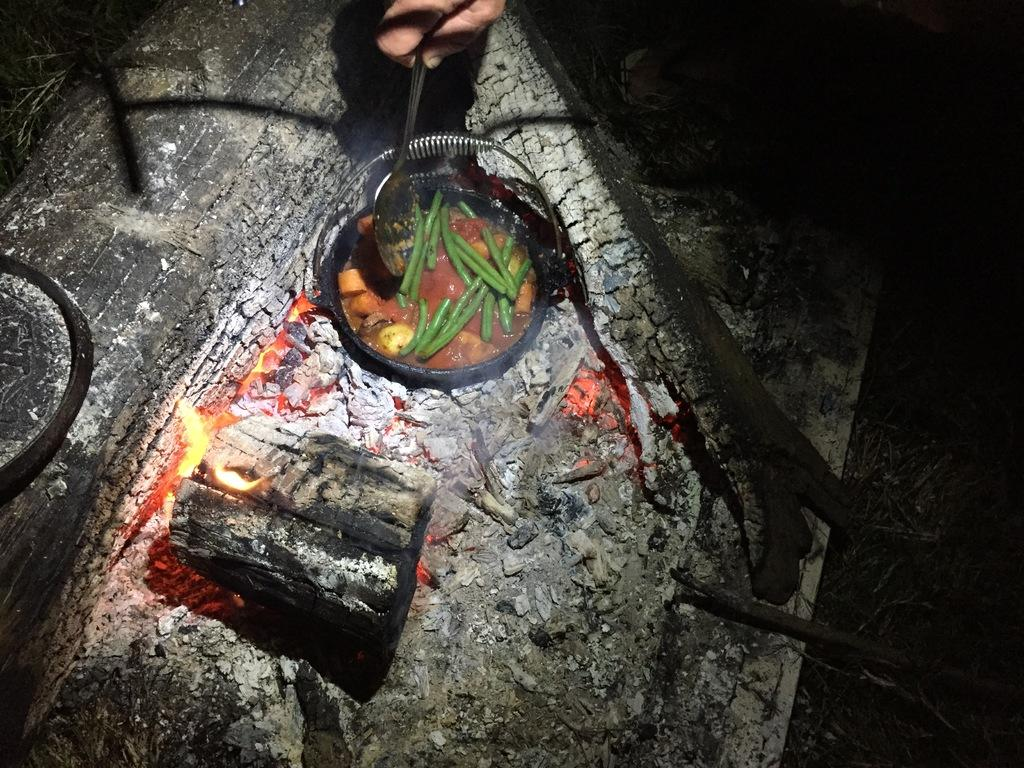What material is present in the image? There is wood in the image. What is happening to the wood in the image? There is fire in the image, which suggests that the wood is being burned. What is the black object in the image? There is a black pan in the image. What is on the black pan? Food is present on the black pan. What is the person in the image doing? The person's hand is visible in the image, and it is holding a spoon. How would you describe the lighting in the image? The image appears to be a bit dark. What type of mint is being used to brush the person's teeth in the image? There is no mint or toothbrushing activity present in the image. What type of vegetable is being cooked on the black pan in the image? The image does not specify the type of food being cooked on the black pan. 